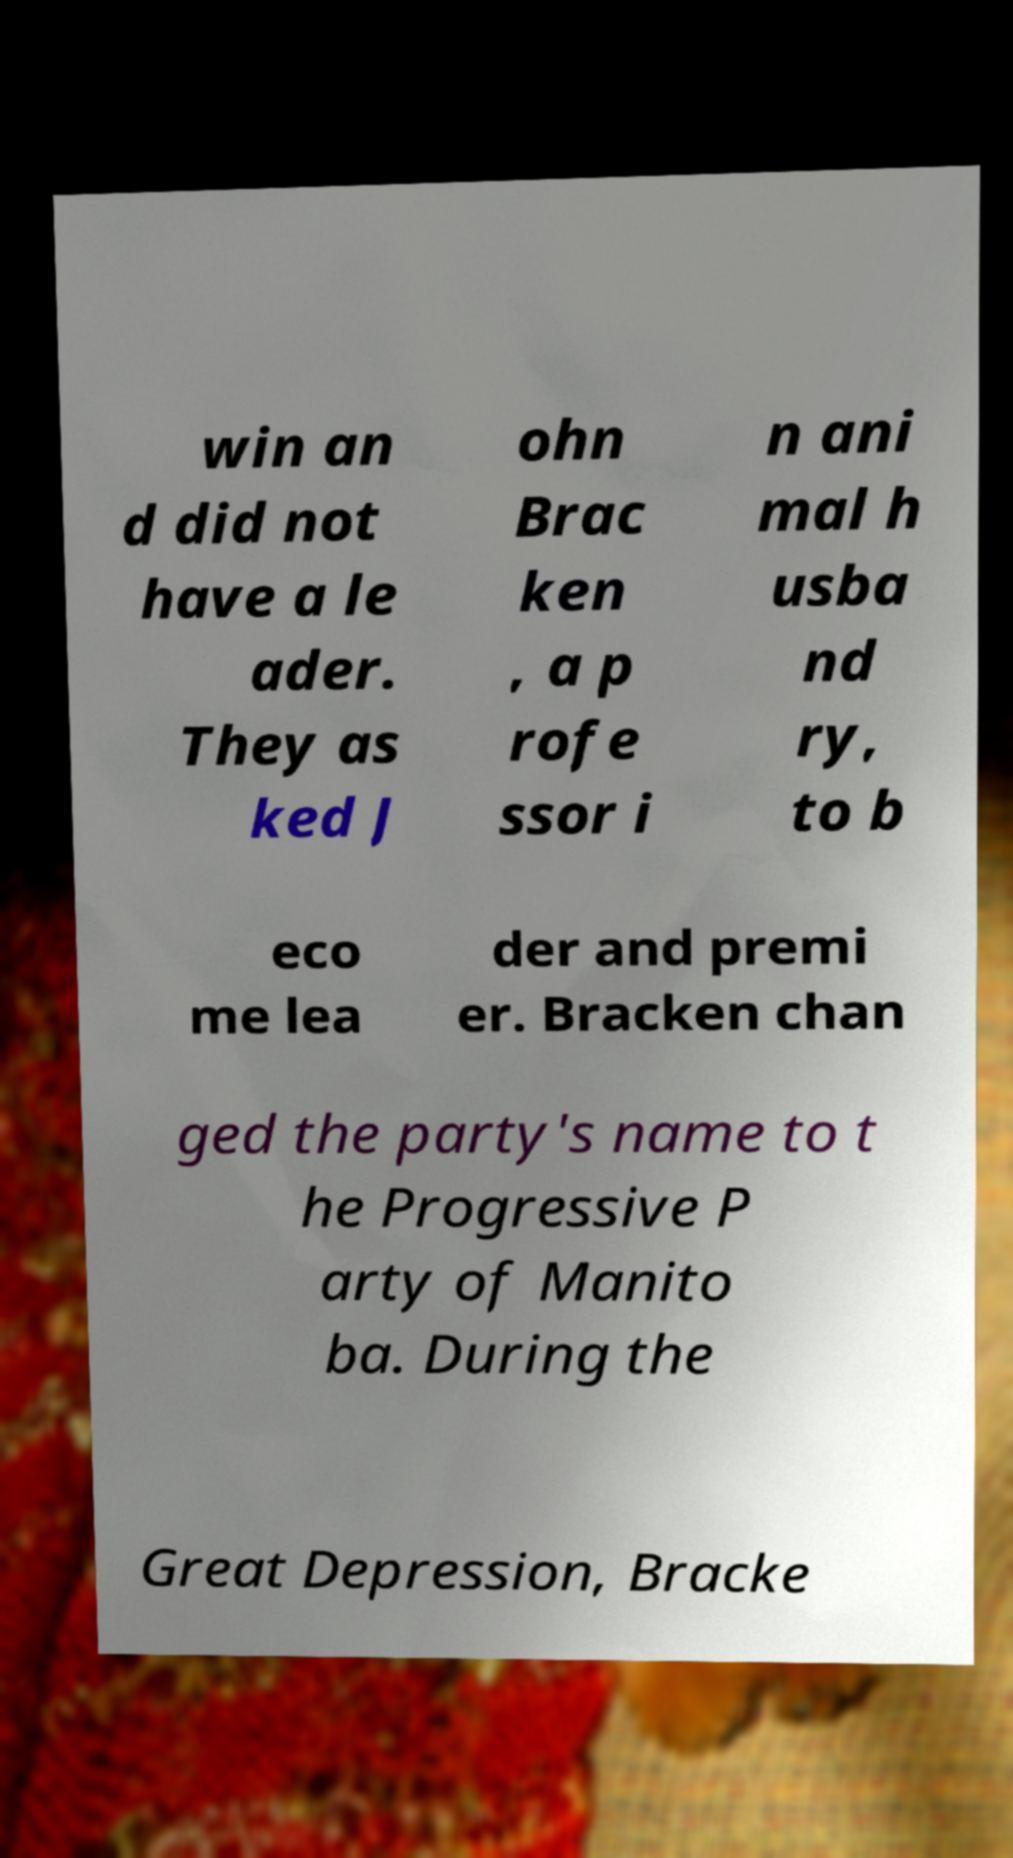Please read and relay the text visible in this image. What does it say? win an d did not have a le ader. They as ked J ohn Brac ken , a p rofe ssor i n ani mal h usba nd ry, to b eco me lea der and premi er. Bracken chan ged the party's name to t he Progressive P arty of Manito ba. During the Great Depression, Bracke 